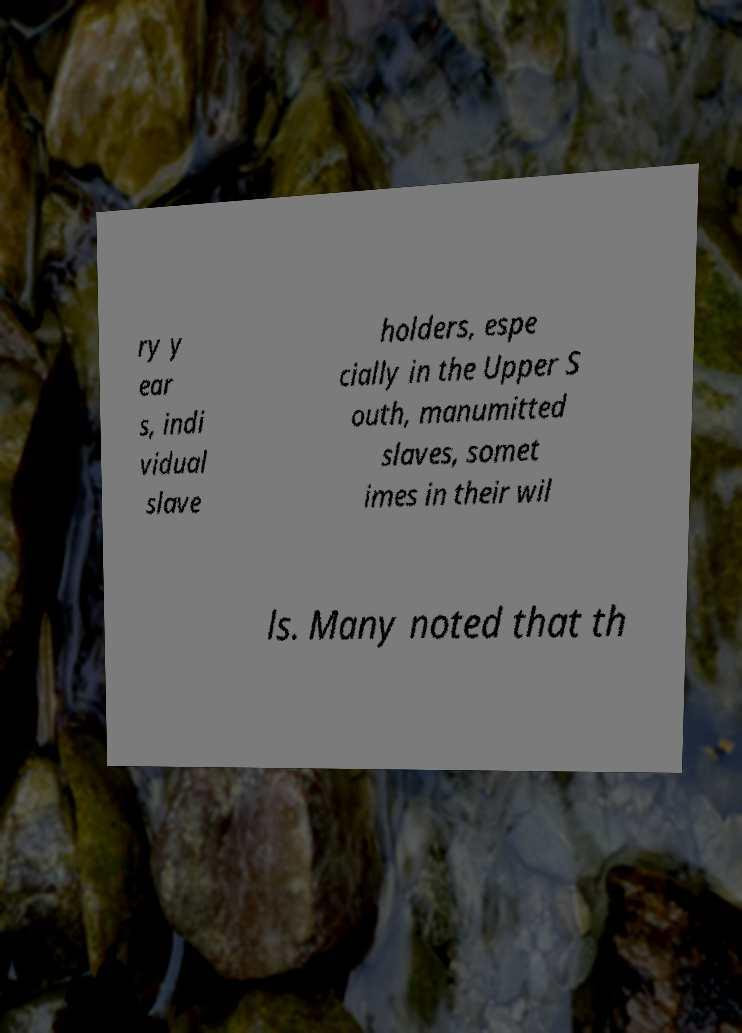For documentation purposes, I need the text within this image transcribed. Could you provide that? ry y ear s, indi vidual slave holders, espe cially in the Upper S outh, manumitted slaves, somet imes in their wil ls. Many noted that th 